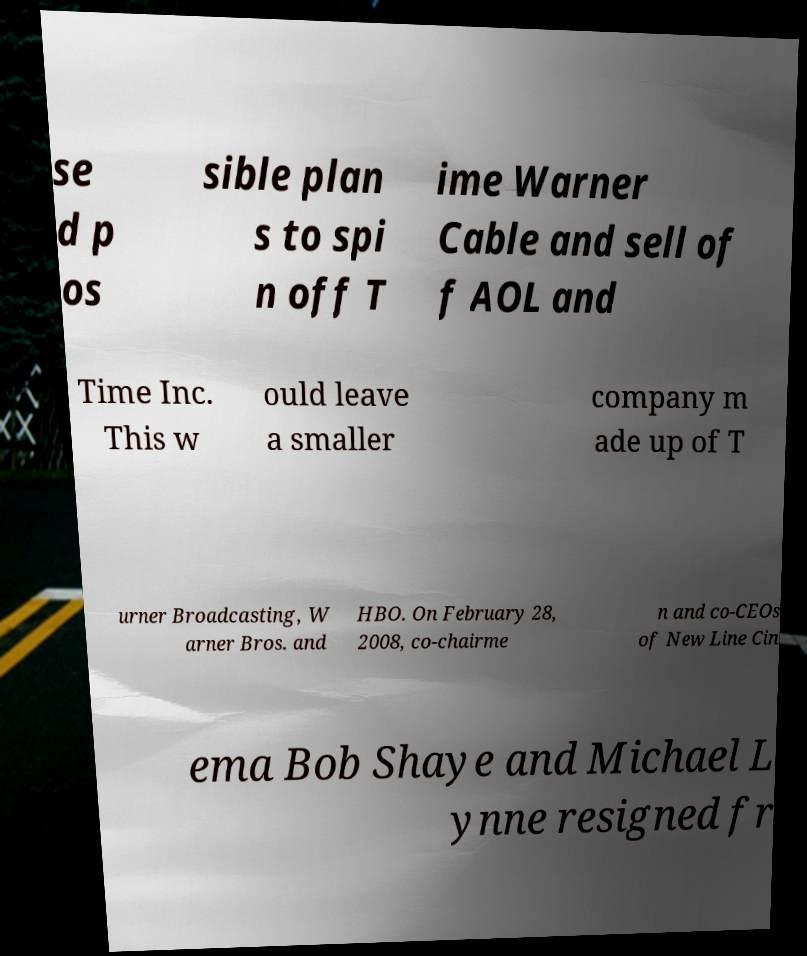For documentation purposes, I need the text within this image transcribed. Could you provide that? se d p os sible plan s to spi n off T ime Warner Cable and sell of f AOL and Time Inc. This w ould leave a smaller company m ade up of T urner Broadcasting, W arner Bros. and HBO. On February 28, 2008, co-chairme n and co-CEOs of New Line Cin ema Bob Shaye and Michael L ynne resigned fr 